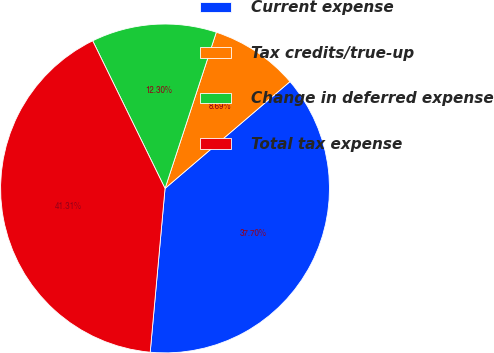<chart> <loc_0><loc_0><loc_500><loc_500><pie_chart><fcel>Current expense<fcel>Tax credits/true-up<fcel>Change in deferred expense<fcel>Total tax expense<nl><fcel>37.7%<fcel>8.69%<fcel>12.3%<fcel>41.31%<nl></chart> 